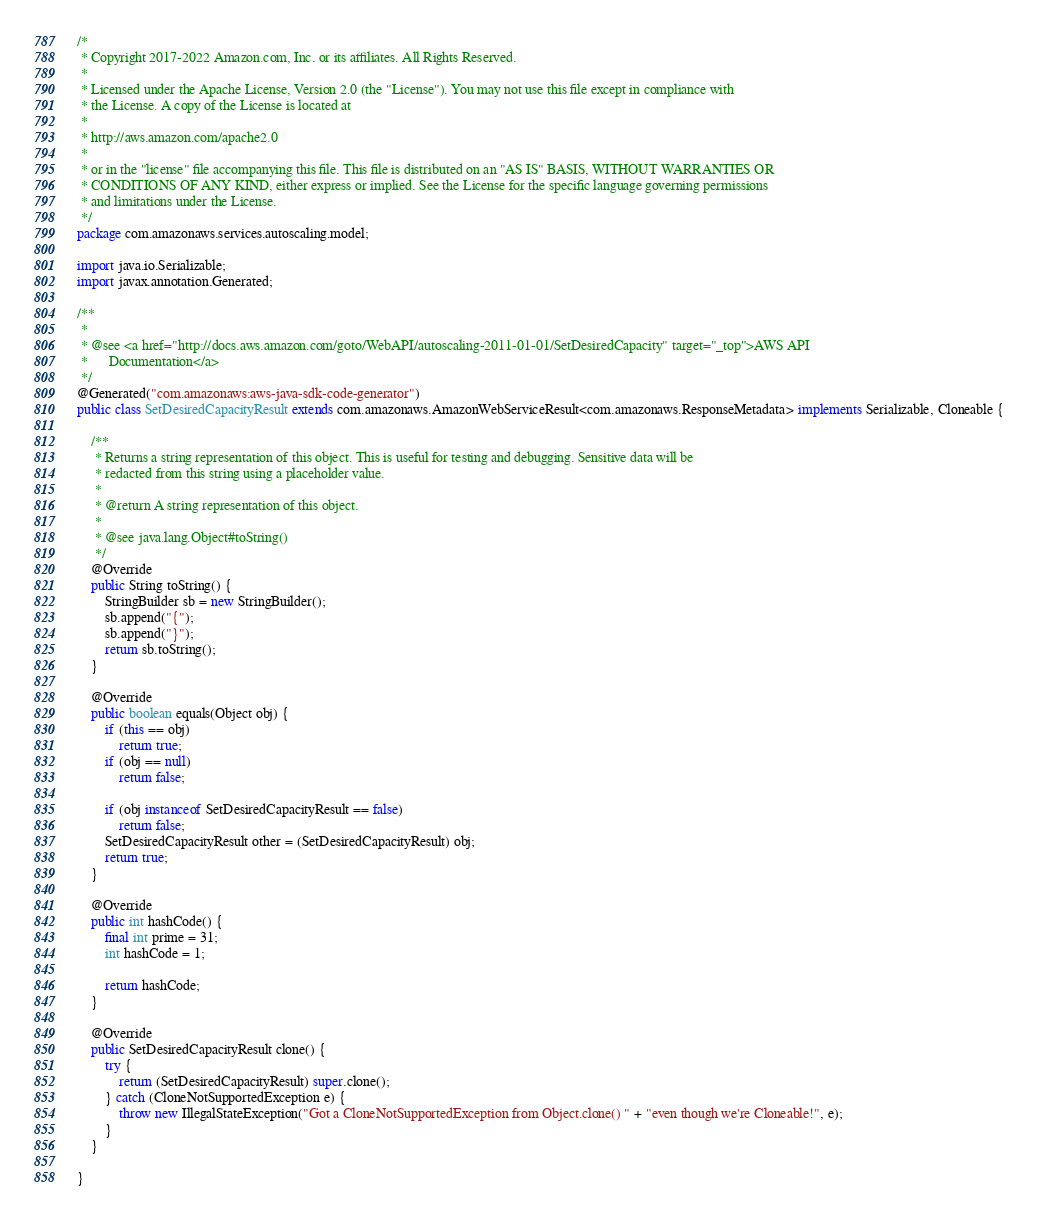<code> <loc_0><loc_0><loc_500><loc_500><_Java_>/*
 * Copyright 2017-2022 Amazon.com, Inc. or its affiliates. All Rights Reserved.
 * 
 * Licensed under the Apache License, Version 2.0 (the "License"). You may not use this file except in compliance with
 * the License. A copy of the License is located at
 * 
 * http://aws.amazon.com/apache2.0
 * 
 * or in the "license" file accompanying this file. This file is distributed on an "AS IS" BASIS, WITHOUT WARRANTIES OR
 * CONDITIONS OF ANY KIND, either express or implied. See the License for the specific language governing permissions
 * and limitations under the License.
 */
package com.amazonaws.services.autoscaling.model;

import java.io.Serializable;
import javax.annotation.Generated;

/**
 * 
 * @see <a href="http://docs.aws.amazon.com/goto/WebAPI/autoscaling-2011-01-01/SetDesiredCapacity" target="_top">AWS API
 *      Documentation</a>
 */
@Generated("com.amazonaws:aws-java-sdk-code-generator")
public class SetDesiredCapacityResult extends com.amazonaws.AmazonWebServiceResult<com.amazonaws.ResponseMetadata> implements Serializable, Cloneable {

    /**
     * Returns a string representation of this object. This is useful for testing and debugging. Sensitive data will be
     * redacted from this string using a placeholder value.
     *
     * @return A string representation of this object.
     *
     * @see java.lang.Object#toString()
     */
    @Override
    public String toString() {
        StringBuilder sb = new StringBuilder();
        sb.append("{");
        sb.append("}");
        return sb.toString();
    }

    @Override
    public boolean equals(Object obj) {
        if (this == obj)
            return true;
        if (obj == null)
            return false;

        if (obj instanceof SetDesiredCapacityResult == false)
            return false;
        SetDesiredCapacityResult other = (SetDesiredCapacityResult) obj;
        return true;
    }

    @Override
    public int hashCode() {
        final int prime = 31;
        int hashCode = 1;

        return hashCode;
    }

    @Override
    public SetDesiredCapacityResult clone() {
        try {
            return (SetDesiredCapacityResult) super.clone();
        } catch (CloneNotSupportedException e) {
            throw new IllegalStateException("Got a CloneNotSupportedException from Object.clone() " + "even though we're Cloneable!", e);
        }
    }

}
</code> 